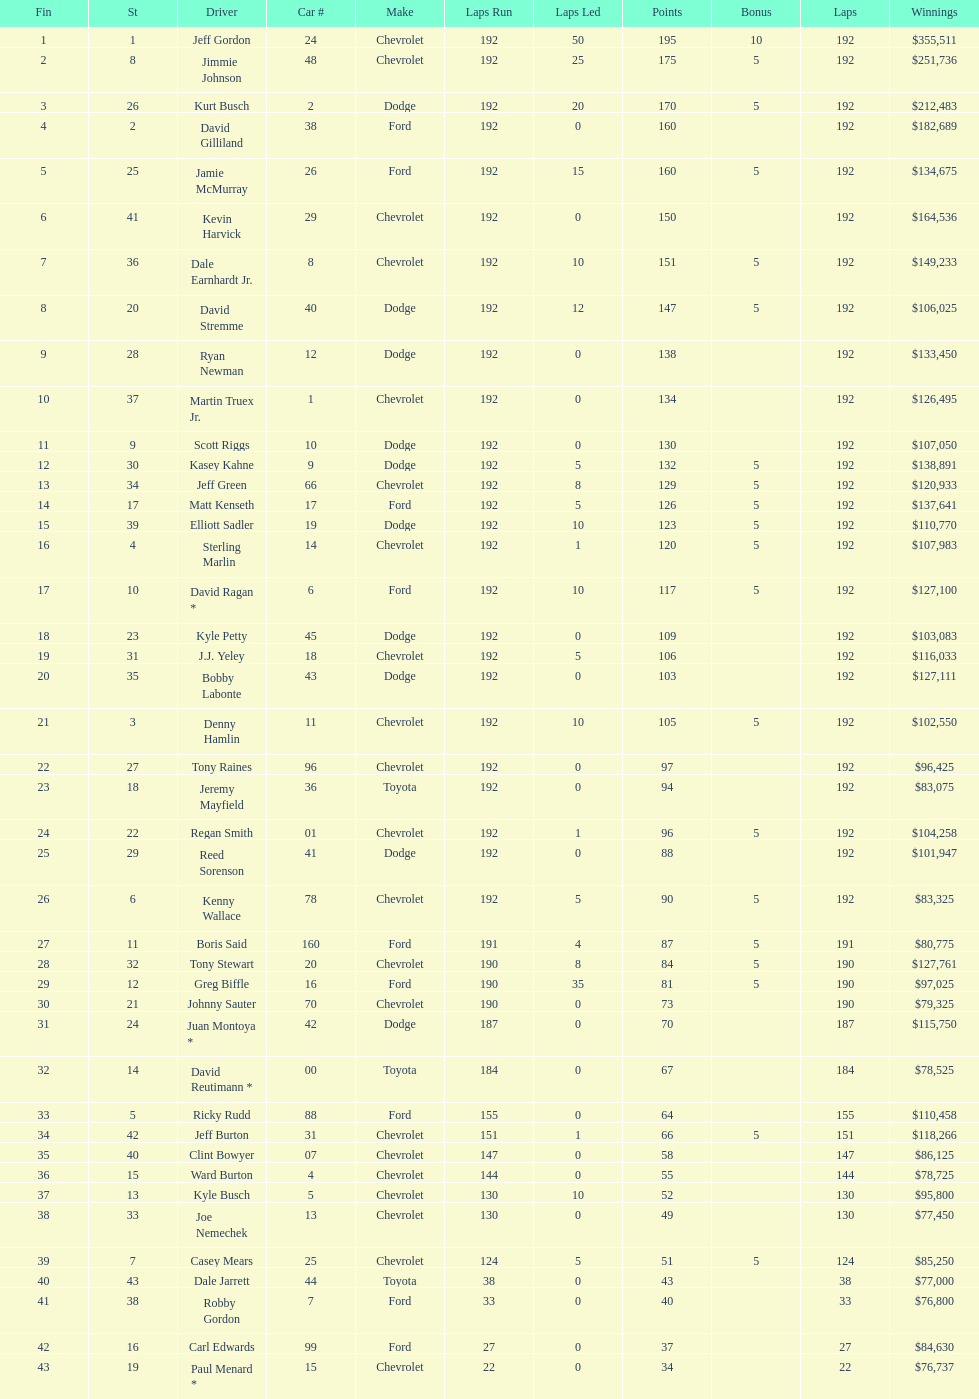How many drivers earned 5 bonus each in the race? 19. 